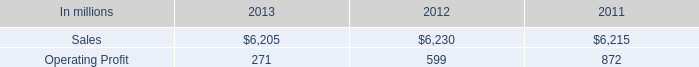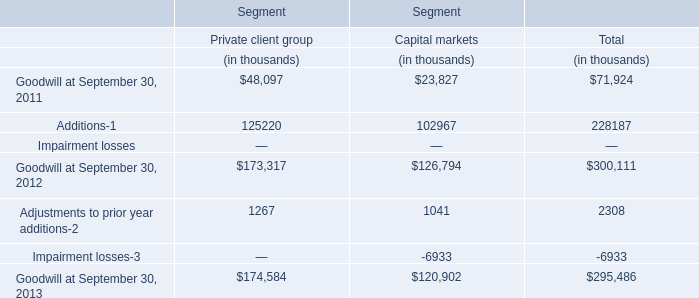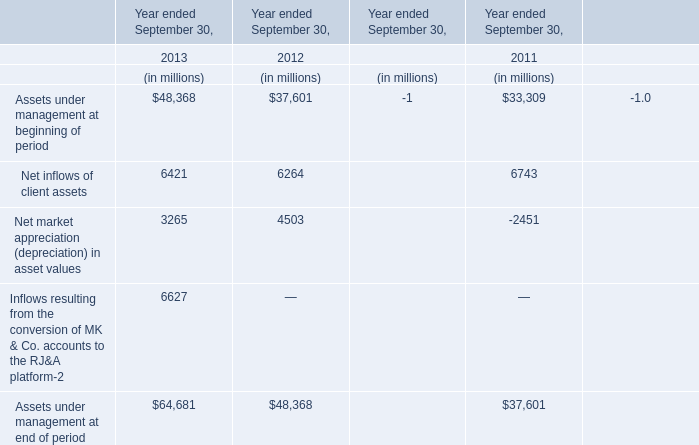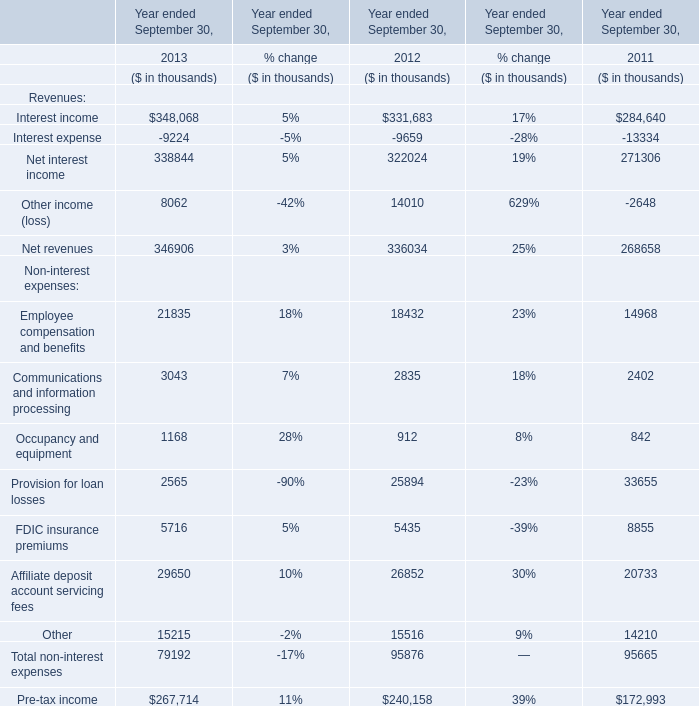In which section the sum of Net revenues has the highest value? 
Answer: 2013. 